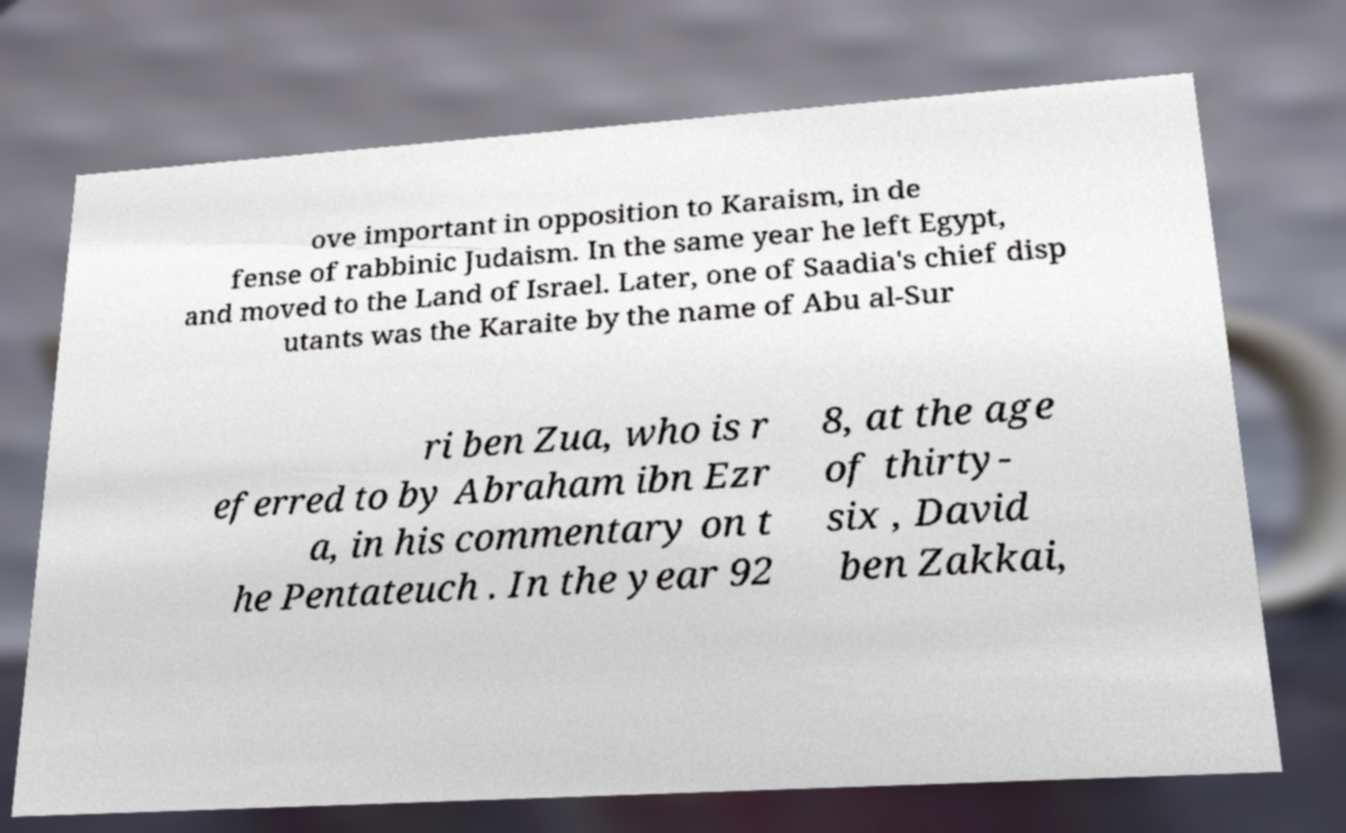What messages or text are displayed in this image? I need them in a readable, typed format. ove important in opposition to Karaism, in de fense of rabbinic Judaism. In the same year he left Egypt, and moved to the Land of Israel. Later, one of Saadia's chief disp utants was the Karaite by the name of Abu al-Sur ri ben Zua, who is r eferred to by Abraham ibn Ezr a, in his commentary on t he Pentateuch . In the year 92 8, at the age of thirty- six , David ben Zakkai, 